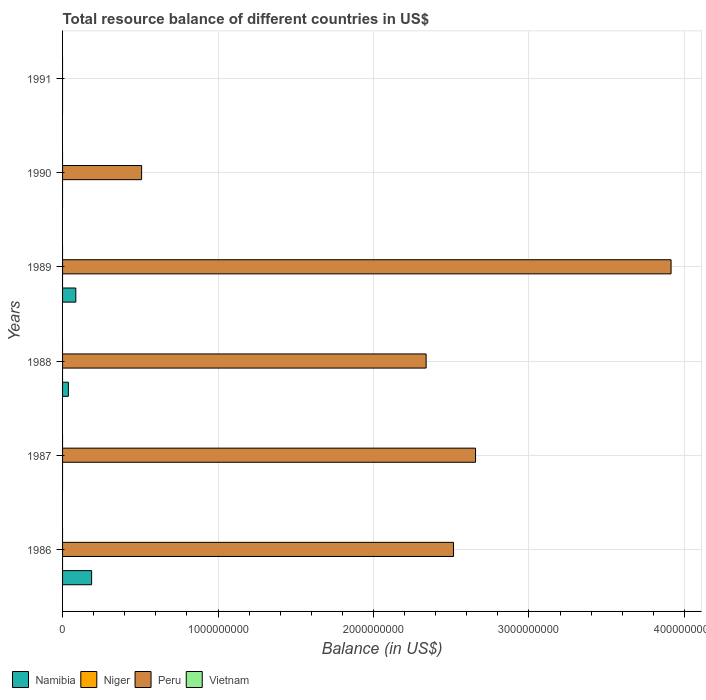How many different coloured bars are there?
Ensure brevity in your answer.  2. Are the number of bars per tick equal to the number of legend labels?
Your answer should be compact. No. How many bars are there on the 1st tick from the bottom?
Keep it short and to the point. 2. What is the label of the 4th group of bars from the top?
Keep it short and to the point. 1988. In how many cases, is the number of bars for a given year not equal to the number of legend labels?
Ensure brevity in your answer.  6. Across all years, what is the maximum total resource balance in Peru?
Make the answer very short. 3.91e+09. Across all years, what is the minimum total resource balance in Niger?
Give a very brief answer. 0. In which year was the total resource balance in Peru maximum?
Your answer should be compact. 1989. What is the total total resource balance in Namibia in the graph?
Ensure brevity in your answer.  3.10e+08. What is the difference between the total resource balance in Peru in 1989 and that in 1990?
Your answer should be very brief. 3.41e+09. What is the difference between the total resource balance in Niger in 1991 and the total resource balance in Namibia in 1989?
Provide a succinct answer. -8.52e+07. What is the average total resource balance in Namibia per year?
Offer a terse response. 5.16e+07. In the year 1988, what is the difference between the total resource balance in Peru and total resource balance in Namibia?
Make the answer very short. 2.30e+09. In how many years, is the total resource balance in Niger greater than 3200000000 US$?
Your response must be concise. 0. What is the ratio of the total resource balance in Peru in 1987 to that in 1988?
Offer a terse response. 1.14. What is the difference between the highest and the second highest total resource balance in Namibia?
Ensure brevity in your answer.  1.02e+08. What is the difference between the highest and the lowest total resource balance in Peru?
Offer a very short reply. 3.91e+09. In how many years, is the total resource balance in Peru greater than the average total resource balance in Peru taken over all years?
Offer a very short reply. 4. Is it the case that in every year, the sum of the total resource balance in Peru and total resource balance in Niger is greater than the sum of total resource balance in Namibia and total resource balance in Vietnam?
Make the answer very short. No. Is it the case that in every year, the sum of the total resource balance in Peru and total resource balance in Vietnam is greater than the total resource balance in Namibia?
Offer a very short reply. No. What is the difference between two consecutive major ticks on the X-axis?
Give a very brief answer. 1.00e+09. Does the graph contain any zero values?
Your answer should be compact. Yes. How are the legend labels stacked?
Offer a very short reply. Horizontal. What is the title of the graph?
Your answer should be very brief. Total resource balance of different countries in US$. Does "Kenya" appear as one of the legend labels in the graph?
Make the answer very short. No. What is the label or title of the X-axis?
Offer a terse response. Balance (in US$). What is the Balance (in US$) of Namibia in 1986?
Your response must be concise. 1.87e+08. What is the Balance (in US$) of Niger in 1986?
Your response must be concise. 0. What is the Balance (in US$) in Peru in 1986?
Give a very brief answer. 2.52e+09. What is the Balance (in US$) of Namibia in 1987?
Your answer should be compact. 0. What is the Balance (in US$) in Niger in 1987?
Your answer should be very brief. 0. What is the Balance (in US$) of Peru in 1987?
Your response must be concise. 2.66e+09. What is the Balance (in US$) of Namibia in 1988?
Keep it short and to the point. 3.75e+07. What is the Balance (in US$) in Peru in 1988?
Give a very brief answer. 2.34e+09. What is the Balance (in US$) of Namibia in 1989?
Provide a succinct answer. 8.52e+07. What is the Balance (in US$) in Peru in 1989?
Your response must be concise. 3.91e+09. What is the Balance (in US$) in Namibia in 1990?
Offer a terse response. 0. What is the Balance (in US$) in Peru in 1990?
Provide a succinct answer. 5.08e+08. What is the Balance (in US$) of Namibia in 1991?
Make the answer very short. 0. What is the Balance (in US$) in Niger in 1991?
Your answer should be very brief. 0. What is the Balance (in US$) in Vietnam in 1991?
Keep it short and to the point. 0. Across all years, what is the maximum Balance (in US$) of Namibia?
Provide a succinct answer. 1.87e+08. Across all years, what is the maximum Balance (in US$) of Peru?
Offer a terse response. 3.91e+09. Across all years, what is the minimum Balance (in US$) of Peru?
Provide a short and direct response. 0. What is the total Balance (in US$) in Namibia in the graph?
Offer a very short reply. 3.10e+08. What is the total Balance (in US$) in Niger in the graph?
Provide a short and direct response. 0. What is the total Balance (in US$) in Peru in the graph?
Offer a very short reply. 1.19e+1. What is the difference between the Balance (in US$) of Peru in 1986 and that in 1987?
Keep it short and to the point. -1.42e+08. What is the difference between the Balance (in US$) in Namibia in 1986 and that in 1988?
Give a very brief answer. 1.49e+08. What is the difference between the Balance (in US$) of Peru in 1986 and that in 1988?
Offer a terse response. 1.76e+08. What is the difference between the Balance (in US$) of Namibia in 1986 and that in 1989?
Your answer should be very brief. 1.02e+08. What is the difference between the Balance (in US$) in Peru in 1986 and that in 1989?
Ensure brevity in your answer.  -1.40e+09. What is the difference between the Balance (in US$) of Peru in 1986 and that in 1990?
Make the answer very short. 2.01e+09. What is the difference between the Balance (in US$) in Peru in 1987 and that in 1988?
Offer a terse response. 3.18e+08. What is the difference between the Balance (in US$) in Peru in 1987 and that in 1989?
Your answer should be compact. -1.26e+09. What is the difference between the Balance (in US$) in Peru in 1987 and that in 1990?
Your answer should be very brief. 2.15e+09. What is the difference between the Balance (in US$) of Namibia in 1988 and that in 1989?
Give a very brief answer. -4.77e+07. What is the difference between the Balance (in US$) of Peru in 1988 and that in 1989?
Make the answer very short. -1.58e+09. What is the difference between the Balance (in US$) of Peru in 1988 and that in 1990?
Provide a succinct answer. 1.83e+09. What is the difference between the Balance (in US$) in Peru in 1989 and that in 1990?
Ensure brevity in your answer.  3.41e+09. What is the difference between the Balance (in US$) of Namibia in 1986 and the Balance (in US$) of Peru in 1987?
Keep it short and to the point. -2.47e+09. What is the difference between the Balance (in US$) of Namibia in 1986 and the Balance (in US$) of Peru in 1988?
Offer a very short reply. -2.15e+09. What is the difference between the Balance (in US$) in Namibia in 1986 and the Balance (in US$) in Peru in 1989?
Your response must be concise. -3.73e+09. What is the difference between the Balance (in US$) of Namibia in 1986 and the Balance (in US$) of Peru in 1990?
Make the answer very short. -3.22e+08. What is the difference between the Balance (in US$) of Namibia in 1988 and the Balance (in US$) of Peru in 1989?
Ensure brevity in your answer.  -3.88e+09. What is the difference between the Balance (in US$) in Namibia in 1988 and the Balance (in US$) in Peru in 1990?
Provide a short and direct response. -4.71e+08. What is the difference between the Balance (in US$) in Namibia in 1989 and the Balance (in US$) in Peru in 1990?
Provide a short and direct response. -4.23e+08. What is the average Balance (in US$) of Namibia per year?
Your answer should be compact. 5.16e+07. What is the average Balance (in US$) in Niger per year?
Offer a very short reply. 0. What is the average Balance (in US$) of Peru per year?
Provide a succinct answer. 1.99e+09. What is the average Balance (in US$) of Vietnam per year?
Provide a short and direct response. 0. In the year 1986, what is the difference between the Balance (in US$) of Namibia and Balance (in US$) of Peru?
Your response must be concise. -2.33e+09. In the year 1988, what is the difference between the Balance (in US$) in Namibia and Balance (in US$) in Peru?
Your response must be concise. -2.30e+09. In the year 1989, what is the difference between the Balance (in US$) in Namibia and Balance (in US$) in Peru?
Offer a terse response. -3.83e+09. What is the ratio of the Balance (in US$) in Peru in 1986 to that in 1987?
Your answer should be very brief. 0.95. What is the ratio of the Balance (in US$) in Namibia in 1986 to that in 1988?
Provide a short and direct response. 4.98. What is the ratio of the Balance (in US$) of Peru in 1986 to that in 1988?
Keep it short and to the point. 1.08. What is the ratio of the Balance (in US$) in Namibia in 1986 to that in 1989?
Ensure brevity in your answer.  2.19. What is the ratio of the Balance (in US$) in Peru in 1986 to that in 1989?
Your answer should be compact. 0.64. What is the ratio of the Balance (in US$) in Peru in 1986 to that in 1990?
Give a very brief answer. 4.95. What is the ratio of the Balance (in US$) in Peru in 1987 to that in 1988?
Give a very brief answer. 1.14. What is the ratio of the Balance (in US$) in Peru in 1987 to that in 1989?
Give a very brief answer. 0.68. What is the ratio of the Balance (in US$) of Peru in 1987 to that in 1990?
Provide a short and direct response. 5.22. What is the ratio of the Balance (in US$) in Namibia in 1988 to that in 1989?
Provide a succinct answer. 0.44. What is the ratio of the Balance (in US$) of Peru in 1988 to that in 1989?
Your answer should be very brief. 0.6. What is the ratio of the Balance (in US$) in Peru in 1988 to that in 1990?
Offer a very short reply. 4.6. What is the ratio of the Balance (in US$) in Peru in 1989 to that in 1990?
Ensure brevity in your answer.  7.7. What is the difference between the highest and the second highest Balance (in US$) of Namibia?
Provide a short and direct response. 1.02e+08. What is the difference between the highest and the second highest Balance (in US$) of Peru?
Offer a very short reply. 1.26e+09. What is the difference between the highest and the lowest Balance (in US$) of Namibia?
Your answer should be compact. 1.87e+08. What is the difference between the highest and the lowest Balance (in US$) in Peru?
Ensure brevity in your answer.  3.91e+09. 